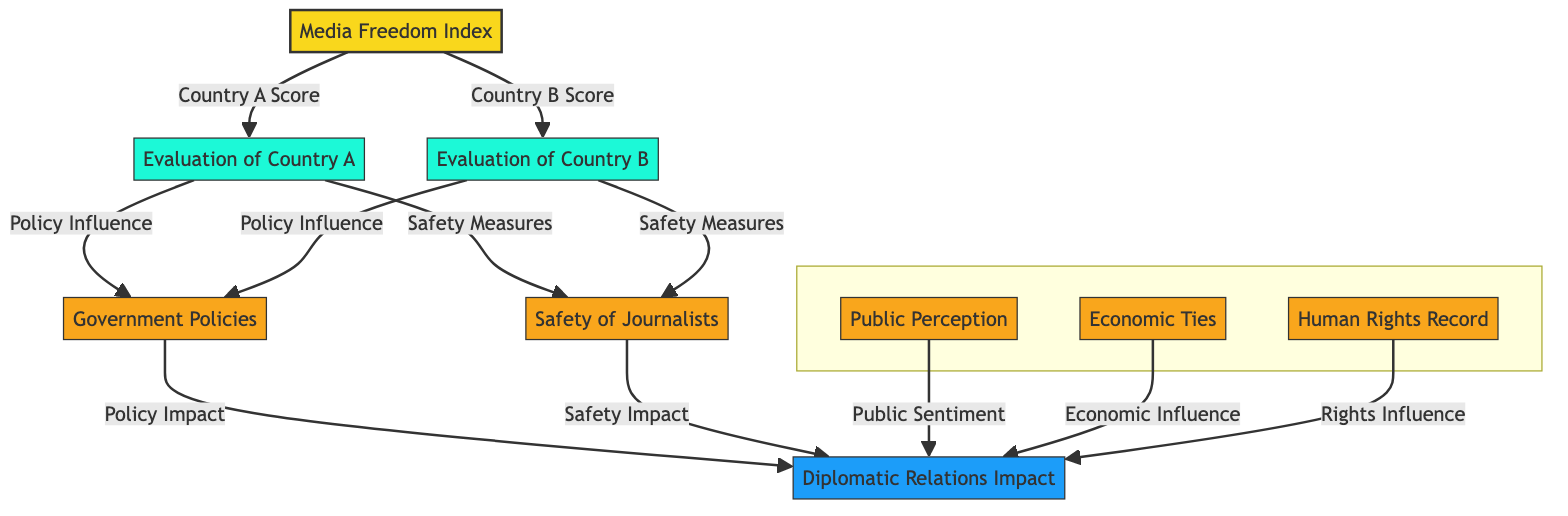What is the central theme of the diagram? The diagram's central theme is represented by the Media Freedom Index, indicating the focus on media freedom across countries.
Answer: Media Freedom Index How many evaluations are there in the diagram? There are two evaluations presented in the diagram, specifically one for Country A and one for Country B.
Answer: 2 Which topic is connected to both Country A and Country B evaluations? The topic connected to both Country A and Country B evaluations is Government Policies, as is indicated by the arrows stemming from both evaluations towards it.
Answer: Government Policies What type of influence does Public Perception have on diplomatic relations? Public Perception influences diplomatic relations through public sentiment, as indicated by the arrow linking them in the diagram.
Answer: Public Sentiment How many key factors are shown in the diagram? The diagram shows three key factors, which are Public Perception, Economic Ties, and Human Rights.
Answer: 3 What influences the Diplomatic Impact according to the diagram? The Diplomatic Impact is influenced by Government Policies, Journalists Safety, Public Perception, Economic Ties, and Human Rights.
Answer: Government Policies, Journalists Safety, Public Perception, Economic Ties, Human Rights Which evaluation connects to Journalists Safety for Country A? The evaluation for Country A connects to Journalists Safety, highlighting the safety measures relevant to that country's media environment.
Answer: Country A Evaluation What specific impact does Journalists Safety have on diplomatic relations? Journalists Safety impacts diplomatic relations by ensuring safety measures which are directly linked in the diagram to the Diplomatic Impact.
Answer: Safety Impact Which node represents the evaluation of Country B? The node representing the evaluation of Country B is labeled "Evaluation of Country B," clearly indicating its focus on that specific country's media situation.
Answer: Evaluation of Country B 